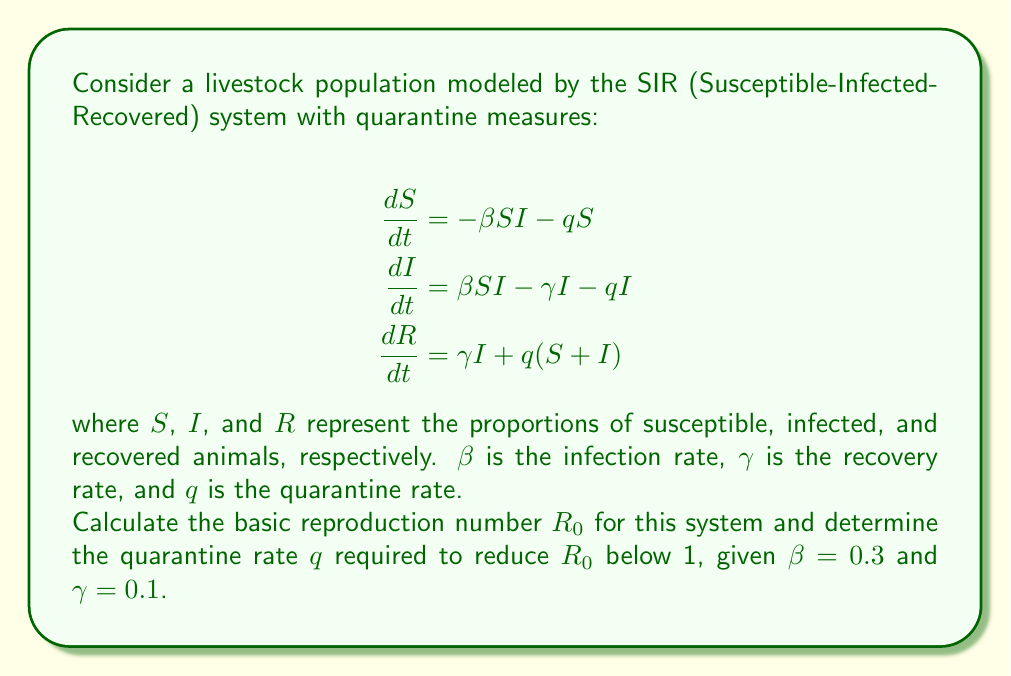Provide a solution to this math problem. To solve this problem, we'll follow these steps:

1) The basic reproduction number $R_0$ represents the average number of secondary infections caused by one infected individual in a completely susceptible population.

2) For the SIR model with quarantine, $R_0$ is given by:

   $$R_0 = \frac{\beta S_0}{\gamma + q}$$

   where $S_0$ is the initial proportion of susceptible animals (usually 1 or close to 1).

3) Assuming $S_0 = 1$, we have:

   $$R_0 = \frac{0.3}{0.1 + q}$$

4) To control the spread of the disease, we need $R_0 < 1$. Let's set up this inequality:

   $$\frac{0.3}{0.1 + q} < 1$$

5) Solve for $q$:
   
   $$0.3 < 0.1 + q$$
   $$0.2 < q$$

6) Therefore, the quarantine rate $q$ must be greater than 0.2 to reduce $R_0$ below 1.

7) We can verify this by calculating $R_0$ with $q = 0.2$:

   $$R_0 = \frac{0.3}{0.1 + 0.2} = 1$$

   Any value of $q$ greater than 0.2 will result in $R_0 < 1$.
Answer: $q > 0.2$ 